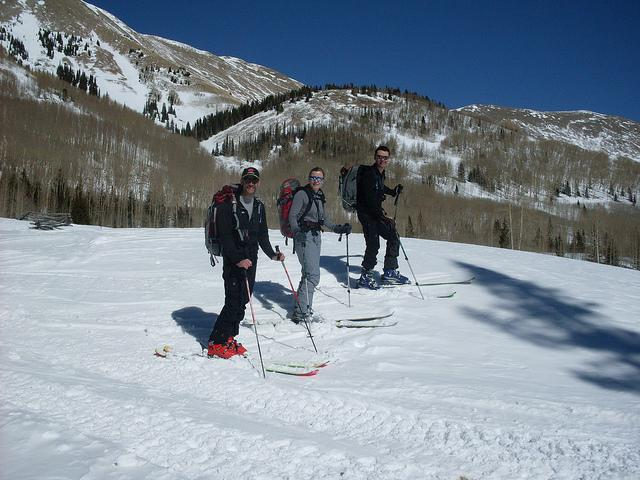Why are they off the path? snow path 